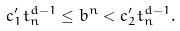<formula> <loc_0><loc_0><loc_500><loc_500>c ^ { \prime } _ { 1 } t _ { n } ^ { d - 1 } \leq b ^ { n } < c ^ { \prime } _ { 2 } t _ { n } ^ { d - 1 } .</formula> 